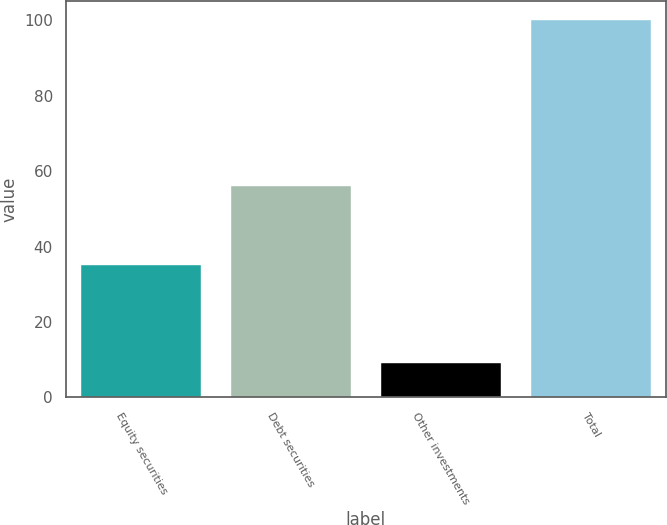Convert chart to OTSL. <chart><loc_0><loc_0><loc_500><loc_500><bar_chart><fcel>Equity securities<fcel>Debt securities<fcel>Other investments<fcel>Total<nl><fcel>35<fcel>56<fcel>9<fcel>100<nl></chart> 